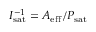<formula> <loc_0><loc_0><loc_500><loc_500>I _ { s a t } ^ { - 1 } = A _ { e f f } / P _ { s a t }</formula> 